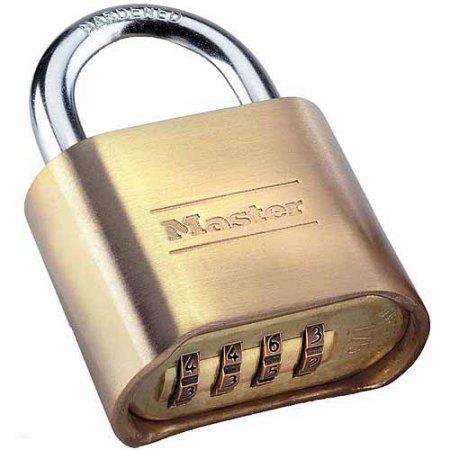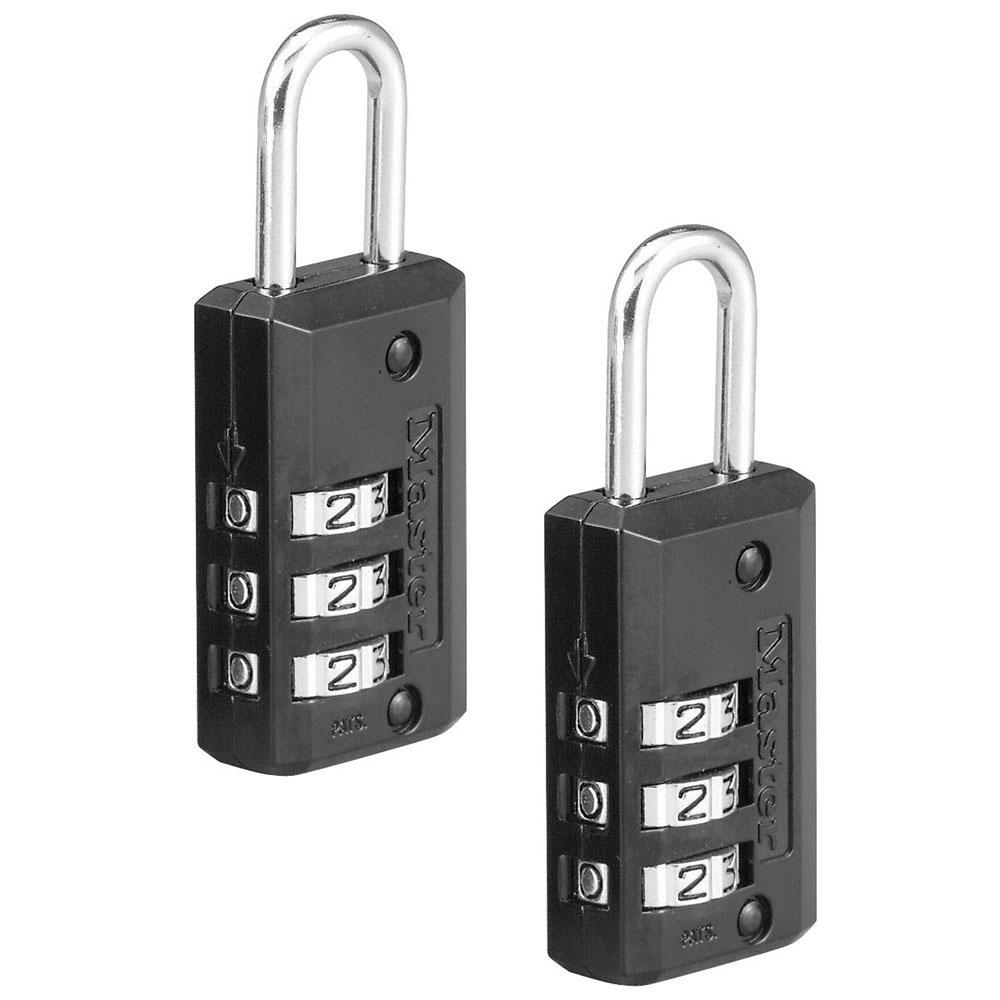The first image is the image on the left, the second image is the image on the right. For the images displayed, is the sentence "The lock in the left image has combination numbers on the bottom of the lock." factually correct? Answer yes or no. Yes. The first image is the image on the left, the second image is the image on the right. Given the left and right images, does the statement "There are two locks total and they are both the same color." hold true? Answer yes or no. No. 